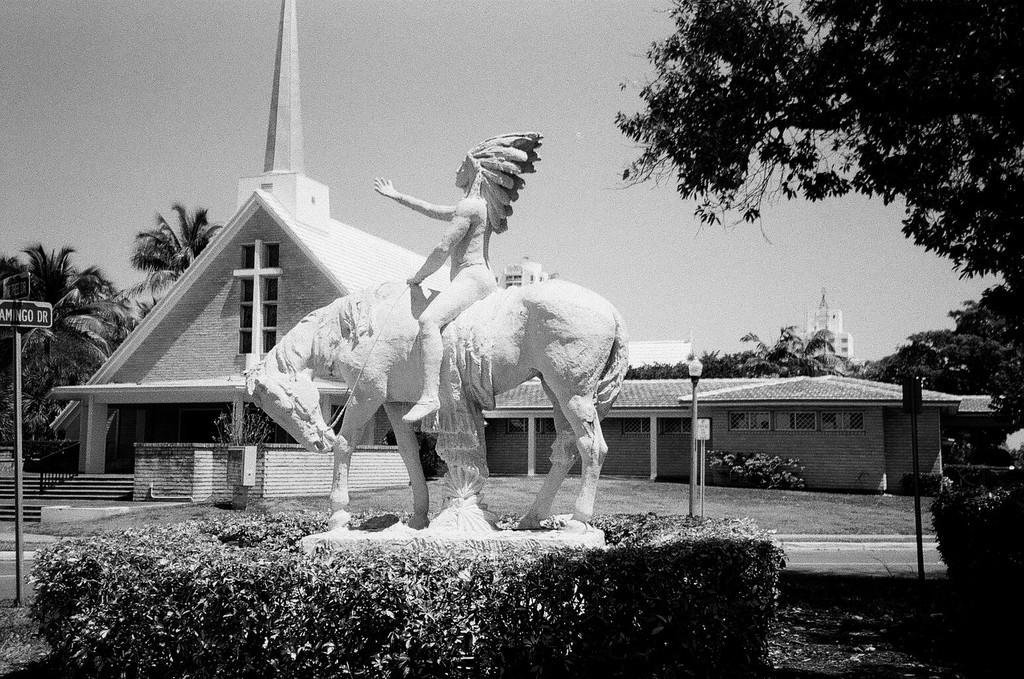What is the main subject in the image? There is a statue on a horse in the image. What is surrounding the statue? The statue is surrounded by plants. What type of building can be seen in the image? There is a building with a cross sign in the image. What else can be seen in the image besides the statue and building? There are poles visible in the image. Are there any cacti visible in the image? There is no mention of cacti in the provided facts, and therefore we cannot determine if any are present in the image. 